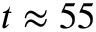Convert formula to latex. <formula><loc_0><loc_0><loc_500><loc_500>t \approx 5 5</formula> 